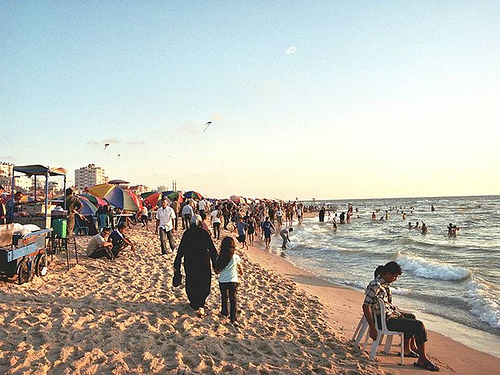Which side of the picture is the blue cart on? The blue cart is situated on the left side of the picture, near some people and umbrellas, closer to the foreground. 